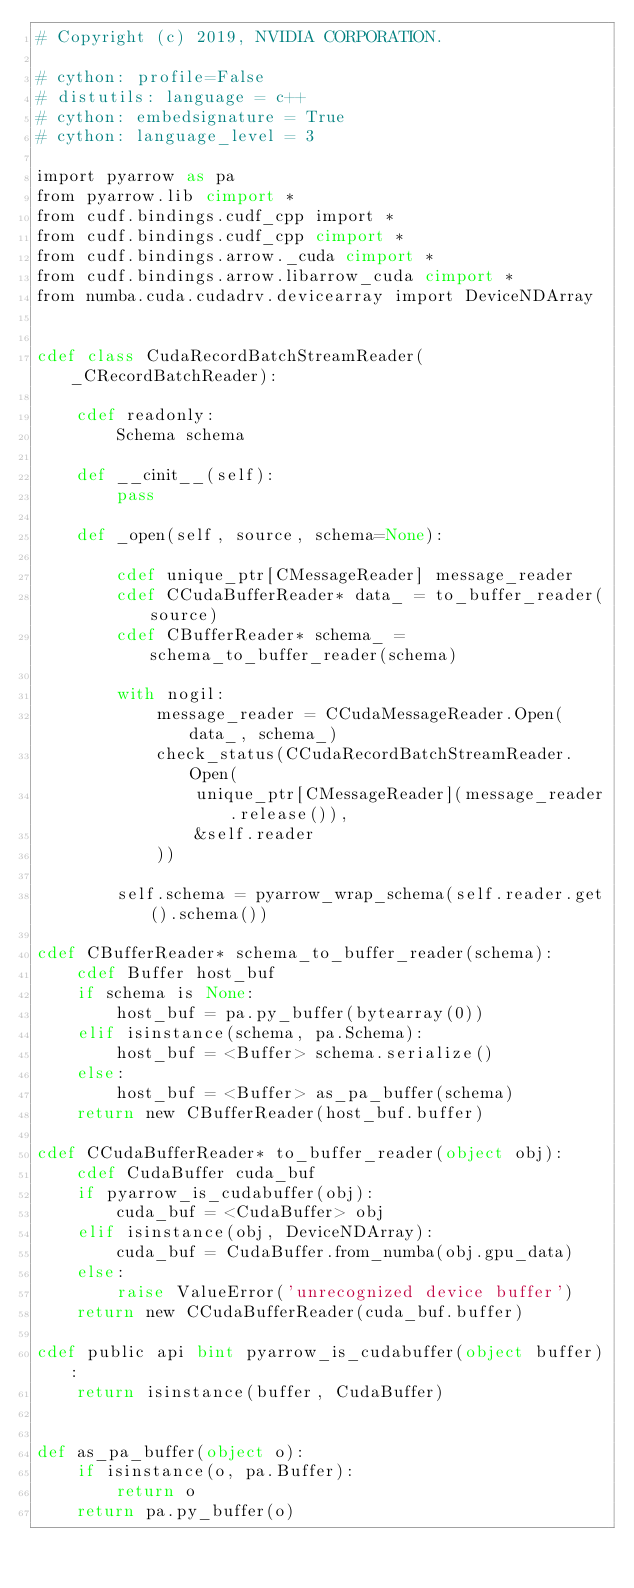<code> <loc_0><loc_0><loc_500><loc_500><_Cython_># Copyright (c) 2019, NVIDIA CORPORATION.

# cython: profile=False
# distutils: language = c++
# cython: embedsignature = True
# cython: language_level = 3

import pyarrow as pa
from pyarrow.lib cimport *
from cudf.bindings.cudf_cpp import *
from cudf.bindings.cudf_cpp cimport *
from cudf.bindings.arrow._cuda cimport *
from cudf.bindings.arrow.libarrow_cuda cimport *
from numba.cuda.cudadrv.devicearray import DeviceNDArray


cdef class CudaRecordBatchStreamReader(_CRecordBatchReader):

    cdef readonly:
        Schema schema

    def __cinit__(self):
        pass

    def _open(self, source, schema=None):

        cdef unique_ptr[CMessageReader] message_reader
        cdef CCudaBufferReader* data_ = to_buffer_reader(source)
        cdef CBufferReader* schema_ = schema_to_buffer_reader(schema)

        with nogil:
            message_reader = CCudaMessageReader.Open(data_, schema_)
            check_status(CCudaRecordBatchStreamReader.Open(
                unique_ptr[CMessageReader](message_reader.release()),
                &self.reader
            ))

        self.schema = pyarrow_wrap_schema(self.reader.get().schema())

cdef CBufferReader* schema_to_buffer_reader(schema):
    cdef Buffer host_buf
    if schema is None:
        host_buf = pa.py_buffer(bytearray(0))
    elif isinstance(schema, pa.Schema):
        host_buf = <Buffer> schema.serialize()
    else:
        host_buf = <Buffer> as_pa_buffer(schema)
    return new CBufferReader(host_buf.buffer)

cdef CCudaBufferReader* to_buffer_reader(object obj):
    cdef CudaBuffer cuda_buf
    if pyarrow_is_cudabuffer(obj):
        cuda_buf = <CudaBuffer> obj
    elif isinstance(obj, DeviceNDArray):
        cuda_buf = CudaBuffer.from_numba(obj.gpu_data)
    else:
        raise ValueError('unrecognized device buffer')
    return new CCudaBufferReader(cuda_buf.buffer)

cdef public api bint pyarrow_is_cudabuffer(object buffer):
    return isinstance(buffer, CudaBuffer)


def as_pa_buffer(object o):
    if isinstance(o, pa.Buffer):
        return o
    return pa.py_buffer(o)
</code> 